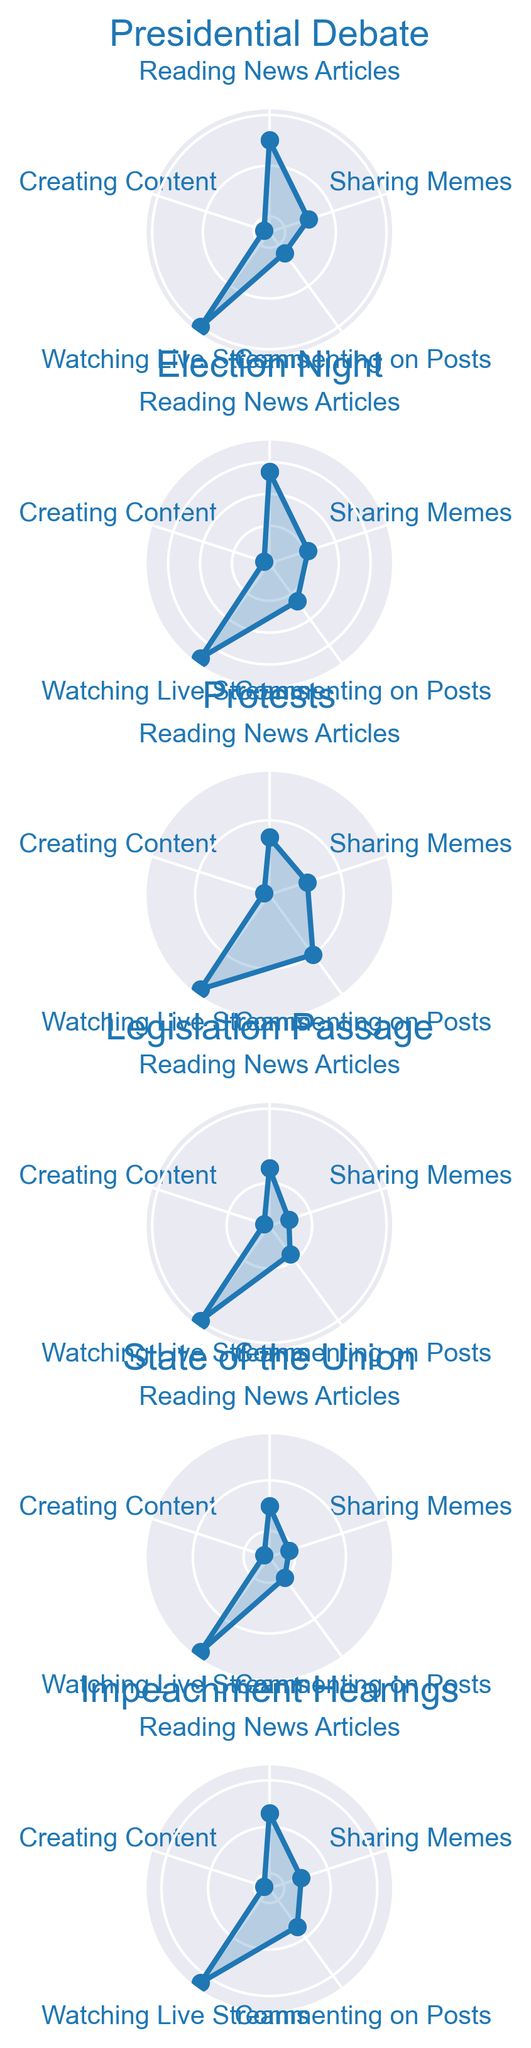What's the most popular behavior during Election Night? Look at the figure for the Election Night section and find the behavior with the longest segment outward. Watching Live Streams has the longest outward segment.
Answer: Watching Live Streams Compare the time spent on Creating Content and Sharing Memes during Presidential Debate. Which behavior had more hours spent? Navigate to the Presidential Debate section of the figure and visually compare the segments for Creating Content and Sharing Memes. The segment for Sharing Memes is longer.
Answer: Sharing Memes Which political event had the highest average hours spent on Commenting on Posts? Calculate the average for each event by summing the hours spent on Commenting on Posts and dividing by the number of behaviors. Election Night has 2.3 hours, which is the highest compared to other events.
Answer: Election Night What is the difference in hours spent on Reading News Articles between Impeachment Hearings and Protests? Find the segments for Reading News Articles for both Impeachment Hearings and Protests. For Impeachment Hearings, the segment is 2.3 hours and for Protests, it is 1.8 hours. The difference is 2.3 - 1.8 = 0.5 hours.
Answer: 0.5 hours What is the combined total hours spent on Watching Live Streams across all political events? Add the hours spent on Watching Live Streams for each political event: 3.0 (Presidential Debate) + 4.5 (Election Night) + 2.5 (Protests) + 2.0 (Legislation Passage) + 2.8 (State of the Union) + 3.2 (Impeachment Hearings) = 18.0 hours.
Answer: 18.0 hours Is there any behavior for which the time spent is consistently less than 1 hour for all political events? Check each political event in the figure to see if any behavior has a segment shorter than 1 hour across all events. Creating Content is less than 1 hour for all events except Election Night and Impeachment Hearings.
Answer: No Between Reading News Articles and Watching Live Streams, which behavior had more hours spent on average during Impeachment Hearings? For Impeachment Hearings, locate the segments for Reading News Articles (2.3 hours) and Watching Live Streams (3.2 hours). Calculate the average if needed, but visually it's clear that Watching Live Streams had higher hours spent.
Answer: Watching Live Streams 